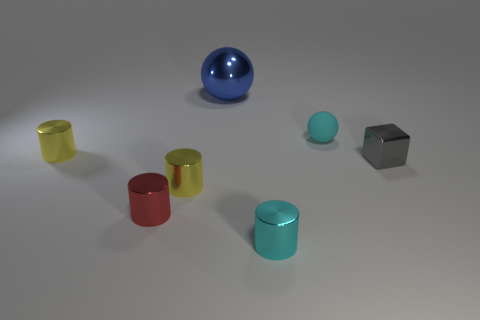Are there any other things that have the same material as the cyan sphere?
Keep it short and to the point. No. Are there more cylinders behind the gray cube than spheres in front of the blue thing?
Make the answer very short. No. Is there a small red thing made of the same material as the small cube?
Ensure brevity in your answer.  Yes. There is a small thing that is both behind the small gray object and to the right of the red thing; what material is it?
Provide a short and direct response. Rubber. The matte thing is what color?
Make the answer very short. Cyan. How many other blue objects are the same shape as the blue thing?
Offer a very short reply. 0. Are the ball behind the cyan matte object and the small cylinder behind the tiny gray shiny thing made of the same material?
Give a very brief answer. Yes. There is a yellow object right of the small yellow metallic cylinder to the left of the red thing; what is its size?
Offer a terse response. Small. Are there any other things that have the same size as the metal ball?
Ensure brevity in your answer.  No. There is a tiny cyan object that is the same shape as the small red metallic thing; what material is it?
Provide a short and direct response. Metal. 